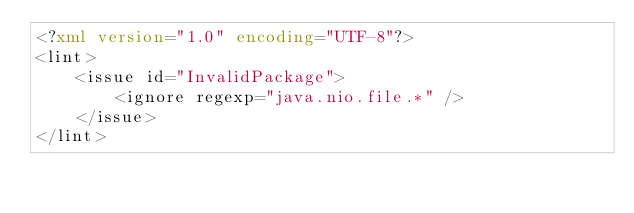Convert code to text. <code><loc_0><loc_0><loc_500><loc_500><_XML_><?xml version="1.0" encoding="UTF-8"?>
<lint>
    <issue id="InvalidPackage">
        <ignore regexp="java.nio.file.*" />
    </issue>
</lint></code> 